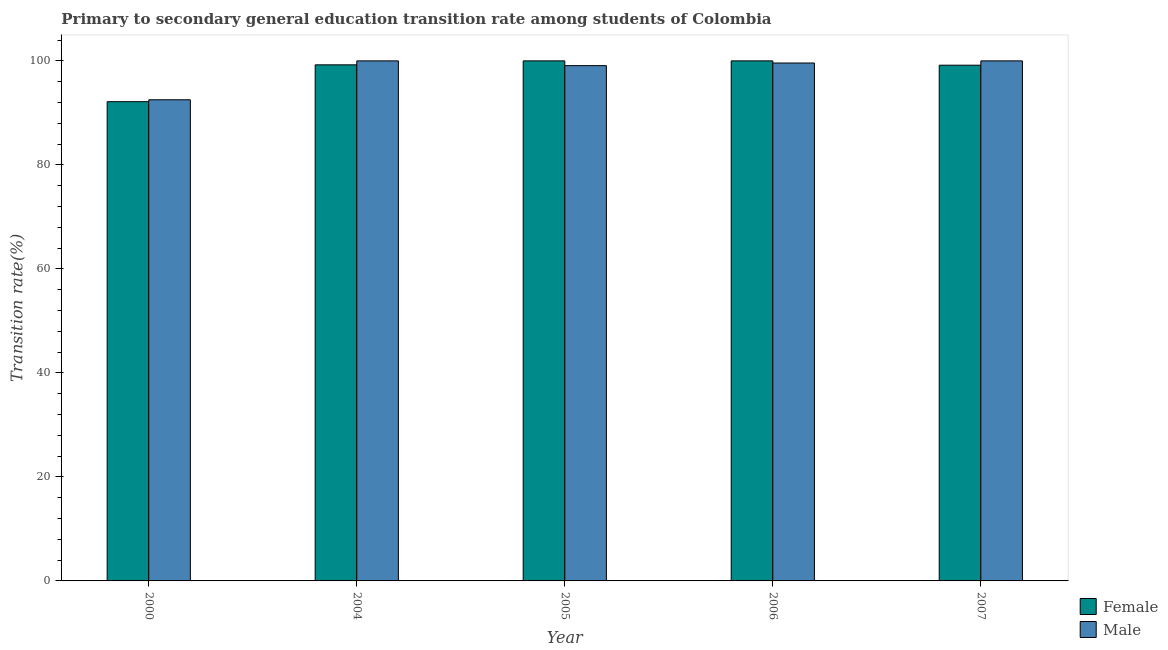How many groups of bars are there?
Provide a short and direct response. 5. In how many cases, is the number of bars for a given year not equal to the number of legend labels?
Keep it short and to the point. 0. Across all years, what is the maximum transition rate among female students?
Make the answer very short. 100. Across all years, what is the minimum transition rate among male students?
Offer a very short reply. 92.52. In which year was the transition rate among female students maximum?
Provide a short and direct response. 2005. In which year was the transition rate among female students minimum?
Make the answer very short. 2000. What is the total transition rate among male students in the graph?
Make the answer very short. 491.19. What is the difference between the transition rate among male students in 2005 and that in 2007?
Provide a short and direct response. -0.92. What is the difference between the transition rate among male students in 2006 and the transition rate among female students in 2004?
Ensure brevity in your answer.  -0.41. What is the average transition rate among female students per year?
Keep it short and to the point. 98.11. In the year 2006, what is the difference between the transition rate among female students and transition rate among male students?
Offer a terse response. 0. In how many years, is the transition rate among female students greater than 56 %?
Offer a very short reply. 5. What is the ratio of the transition rate among female students in 2000 to that in 2007?
Ensure brevity in your answer.  0.93. Is the transition rate among male students in 2000 less than that in 2005?
Offer a terse response. Yes. What is the difference between the highest and the second highest transition rate among male students?
Your answer should be very brief. 0. What is the difference between the highest and the lowest transition rate among female students?
Offer a terse response. 7.85. In how many years, is the transition rate among female students greater than the average transition rate among female students taken over all years?
Offer a terse response. 4. Is the sum of the transition rate among female students in 2004 and 2006 greater than the maximum transition rate among male students across all years?
Keep it short and to the point. Yes. How many bars are there?
Give a very brief answer. 10. Are the values on the major ticks of Y-axis written in scientific E-notation?
Offer a very short reply. No. How are the legend labels stacked?
Make the answer very short. Vertical. What is the title of the graph?
Your answer should be very brief. Primary to secondary general education transition rate among students of Colombia. What is the label or title of the Y-axis?
Your answer should be very brief. Transition rate(%). What is the Transition rate(%) of Female in 2000?
Offer a very short reply. 92.15. What is the Transition rate(%) in Male in 2000?
Your answer should be very brief. 92.52. What is the Transition rate(%) in Female in 2004?
Your answer should be very brief. 99.24. What is the Transition rate(%) of Female in 2005?
Give a very brief answer. 100. What is the Transition rate(%) of Male in 2005?
Ensure brevity in your answer.  99.08. What is the Transition rate(%) in Male in 2006?
Your answer should be very brief. 99.59. What is the Transition rate(%) of Female in 2007?
Your response must be concise. 99.17. Across all years, what is the maximum Transition rate(%) in Female?
Offer a very short reply. 100. Across all years, what is the maximum Transition rate(%) in Male?
Make the answer very short. 100. Across all years, what is the minimum Transition rate(%) in Female?
Make the answer very short. 92.15. Across all years, what is the minimum Transition rate(%) of Male?
Offer a terse response. 92.52. What is the total Transition rate(%) of Female in the graph?
Ensure brevity in your answer.  490.56. What is the total Transition rate(%) of Male in the graph?
Offer a very short reply. 491.19. What is the difference between the Transition rate(%) in Female in 2000 and that in 2004?
Your answer should be compact. -7.08. What is the difference between the Transition rate(%) of Male in 2000 and that in 2004?
Your answer should be compact. -7.48. What is the difference between the Transition rate(%) in Female in 2000 and that in 2005?
Keep it short and to the point. -7.85. What is the difference between the Transition rate(%) of Male in 2000 and that in 2005?
Your answer should be compact. -6.56. What is the difference between the Transition rate(%) in Female in 2000 and that in 2006?
Your answer should be very brief. -7.85. What is the difference between the Transition rate(%) of Male in 2000 and that in 2006?
Provide a short and direct response. -7.07. What is the difference between the Transition rate(%) in Female in 2000 and that in 2007?
Provide a succinct answer. -7.02. What is the difference between the Transition rate(%) of Male in 2000 and that in 2007?
Ensure brevity in your answer.  -7.48. What is the difference between the Transition rate(%) of Female in 2004 and that in 2005?
Make the answer very short. -0.76. What is the difference between the Transition rate(%) in Male in 2004 and that in 2005?
Your response must be concise. 0.92. What is the difference between the Transition rate(%) of Female in 2004 and that in 2006?
Offer a terse response. -0.76. What is the difference between the Transition rate(%) in Male in 2004 and that in 2006?
Ensure brevity in your answer.  0.41. What is the difference between the Transition rate(%) in Female in 2004 and that in 2007?
Provide a short and direct response. 0.07. What is the difference between the Transition rate(%) of Male in 2004 and that in 2007?
Provide a short and direct response. 0. What is the difference between the Transition rate(%) in Male in 2005 and that in 2006?
Keep it short and to the point. -0.51. What is the difference between the Transition rate(%) in Female in 2005 and that in 2007?
Provide a short and direct response. 0.83. What is the difference between the Transition rate(%) of Male in 2005 and that in 2007?
Make the answer very short. -0.92. What is the difference between the Transition rate(%) in Female in 2006 and that in 2007?
Provide a succinct answer. 0.83. What is the difference between the Transition rate(%) of Male in 2006 and that in 2007?
Keep it short and to the point. -0.41. What is the difference between the Transition rate(%) of Female in 2000 and the Transition rate(%) of Male in 2004?
Make the answer very short. -7.85. What is the difference between the Transition rate(%) in Female in 2000 and the Transition rate(%) in Male in 2005?
Provide a succinct answer. -6.93. What is the difference between the Transition rate(%) of Female in 2000 and the Transition rate(%) of Male in 2006?
Provide a succinct answer. -7.44. What is the difference between the Transition rate(%) of Female in 2000 and the Transition rate(%) of Male in 2007?
Keep it short and to the point. -7.85. What is the difference between the Transition rate(%) in Female in 2004 and the Transition rate(%) in Male in 2005?
Make the answer very short. 0.16. What is the difference between the Transition rate(%) in Female in 2004 and the Transition rate(%) in Male in 2006?
Your answer should be very brief. -0.35. What is the difference between the Transition rate(%) of Female in 2004 and the Transition rate(%) of Male in 2007?
Your response must be concise. -0.76. What is the difference between the Transition rate(%) in Female in 2005 and the Transition rate(%) in Male in 2006?
Give a very brief answer. 0.41. What is the difference between the Transition rate(%) in Female in 2005 and the Transition rate(%) in Male in 2007?
Your answer should be compact. 0. What is the difference between the Transition rate(%) in Female in 2006 and the Transition rate(%) in Male in 2007?
Your answer should be very brief. 0. What is the average Transition rate(%) of Female per year?
Ensure brevity in your answer.  98.11. What is the average Transition rate(%) of Male per year?
Give a very brief answer. 98.24. In the year 2000, what is the difference between the Transition rate(%) of Female and Transition rate(%) of Male?
Keep it short and to the point. -0.37. In the year 2004, what is the difference between the Transition rate(%) of Female and Transition rate(%) of Male?
Provide a short and direct response. -0.76. In the year 2005, what is the difference between the Transition rate(%) in Female and Transition rate(%) in Male?
Offer a terse response. 0.92. In the year 2006, what is the difference between the Transition rate(%) in Female and Transition rate(%) in Male?
Offer a terse response. 0.41. In the year 2007, what is the difference between the Transition rate(%) of Female and Transition rate(%) of Male?
Offer a terse response. -0.83. What is the ratio of the Transition rate(%) in Male in 2000 to that in 2004?
Your answer should be compact. 0.93. What is the ratio of the Transition rate(%) in Female in 2000 to that in 2005?
Provide a short and direct response. 0.92. What is the ratio of the Transition rate(%) of Male in 2000 to that in 2005?
Provide a short and direct response. 0.93. What is the ratio of the Transition rate(%) of Female in 2000 to that in 2006?
Make the answer very short. 0.92. What is the ratio of the Transition rate(%) in Male in 2000 to that in 2006?
Your response must be concise. 0.93. What is the ratio of the Transition rate(%) of Female in 2000 to that in 2007?
Your answer should be very brief. 0.93. What is the ratio of the Transition rate(%) of Male in 2000 to that in 2007?
Provide a succinct answer. 0.93. What is the ratio of the Transition rate(%) of Male in 2004 to that in 2005?
Make the answer very short. 1.01. What is the ratio of the Transition rate(%) in Female in 2004 to that in 2006?
Your answer should be very brief. 0.99. What is the ratio of the Transition rate(%) of Female in 2004 to that in 2007?
Your answer should be compact. 1. What is the ratio of the Transition rate(%) in Male in 2004 to that in 2007?
Give a very brief answer. 1. What is the ratio of the Transition rate(%) in Male in 2005 to that in 2006?
Make the answer very short. 0.99. What is the ratio of the Transition rate(%) of Female in 2005 to that in 2007?
Offer a terse response. 1.01. What is the ratio of the Transition rate(%) of Female in 2006 to that in 2007?
Make the answer very short. 1.01. What is the ratio of the Transition rate(%) of Male in 2006 to that in 2007?
Ensure brevity in your answer.  1. What is the difference between the highest and the second highest Transition rate(%) of Female?
Provide a short and direct response. 0. What is the difference between the highest and the second highest Transition rate(%) of Male?
Offer a terse response. 0. What is the difference between the highest and the lowest Transition rate(%) of Female?
Offer a terse response. 7.85. What is the difference between the highest and the lowest Transition rate(%) in Male?
Offer a very short reply. 7.48. 